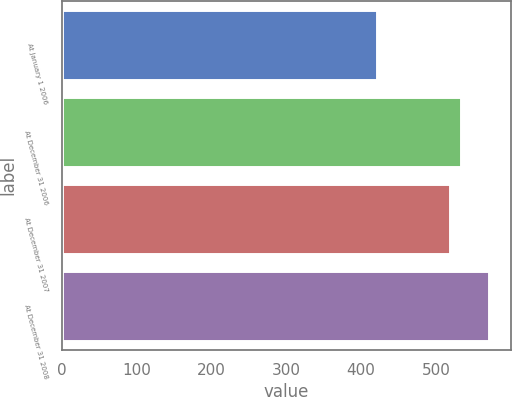<chart> <loc_0><loc_0><loc_500><loc_500><bar_chart><fcel>At January 1 2006<fcel>At December 31 2006<fcel>At December 31 2007<fcel>At December 31 2008<nl><fcel>421<fcel>533<fcel>518<fcel>571<nl></chart> 